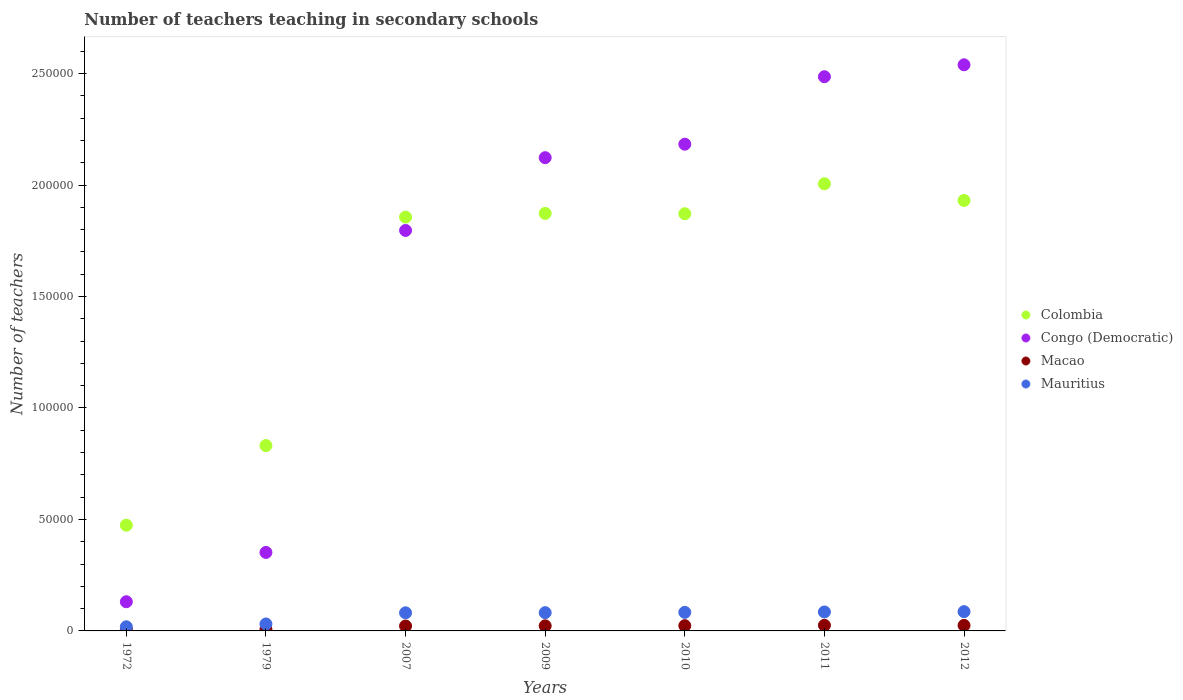What is the number of teachers teaching in secondary schools in Congo (Democratic) in 2007?
Provide a short and direct response. 1.80e+05. Across all years, what is the maximum number of teachers teaching in secondary schools in Colombia?
Provide a short and direct response. 2.01e+05. Across all years, what is the minimum number of teachers teaching in secondary schools in Macao?
Ensure brevity in your answer.  668. In which year was the number of teachers teaching in secondary schools in Macao maximum?
Keep it short and to the point. 2011. In which year was the number of teachers teaching in secondary schools in Congo (Democratic) minimum?
Give a very brief answer. 1972. What is the total number of teachers teaching in secondary schools in Mauritius in the graph?
Keep it short and to the point. 4.68e+04. What is the difference between the number of teachers teaching in secondary schools in Macao in 2010 and that in 2011?
Offer a terse response. -168. What is the difference between the number of teachers teaching in secondary schools in Congo (Democratic) in 1972 and the number of teachers teaching in secondary schools in Macao in 2010?
Offer a terse response. 1.07e+04. What is the average number of teachers teaching in secondary schools in Mauritius per year?
Your answer should be compact. 6680.57. In the year 2007, what is the difference between the number of teachers teaching in secondary schools in Macao and number of teachers teaching in secondary schools in Mauritius?
Keep it short and to the point. -5914. What is the ratio of the number of teachers teaching in secondary schools in Colombia in 1979 to that in 2007?
Ensure brevity in your answer.  0.45. Is the number of teachers teaching in secondary schools in Macao in 1972 less than that in 2012?
Give a very brief answer. Yes. Is the difference between the number of teachers teaching in secondary schools in Macao in 1972 and 2009 greater than the difference between the number of teachers teaching in secondary schools in Mauritius in 1972 and 2009?
Give a very brief answer. Yes. What is the difference between the highest and the second highest number of teachers teaching in secondary schools in Mauritius?
Offer a terse response. 136. What is the difference between the highest and the lowest number of teachers teaching in secondary schools in Mauritius?
Offer a terse response. 6787. Is the sum of the number of teachers teaching in secondary schools in Congo (Democratic) in 2009 and 2012 greater than the maximum number of teachers teaching in secondary schools in Macao across all years?
Your response must be concise. Yes. Is it the case that in every year, the sum of the number of teachers teaching in secondary schools in Mauritius and number of teachers teaching in secondary schools in Macao  is greater than the number of teachers teaching in secondary schools in Congo (Democratic)?
Give a very brief answer. No. Is the number of teachers teaching in secondary schools in Macao strictly less than the number of teachers teaching in secondary schools in Congo (Democratic) over the years?
Your response must be concise. Yes. How many dotlines are there?
Offer a terse response. 4. How many years are there in the graph?
Ensure brevity in your answer.  7. Are the values on the major ticks of Y-axis written in scientific E-notation?
Make the answer very short. No. What is the title of the graph?
Ensure brevity in your answer.  Number of teachers teaching in secondary schools. Does "Least developed countries" appear as one of the legend labels in the graph?
Make the answer very short. No. What is the label or title of the Y-axis?
Ensure brevity in your answer.  Number of teachers. What is the Number of teachers of Colombia in 1972?
Your answer should be compact. 4.74e+04. What is the Number of teachers of Congo (Democratic) in 1972?
Give a very brief answer. 1.31e+04. What is the Number of teachers in Macao in 1972?
Ensure brevity in your answer.  668. What is the Number of teachers in Mauritius in 1972?
Offer a very short reply. 1856. What is the Number of teachers of Colombia in 1979?
Keep it short and to the point. 8.31e+04. What is the Number of teachers of Congo (Democratic) in 1979?
Provide a short and direct response. 3.52e+04. What is the Number of teachers in Macao in 1979?
Your response must be concise. 716. What is the Number of teachers in Mauritius in 1979?
Your response must be concise. 3125. What is the Number of teachers of Colombia in 2007?
Give a very brief answer. 1.86e+05. What is the Number of teachers in Congo (Democratic) in 2007?
Provide a succinct answer. 1.80e+05. What is the Number of teachers in Macao in 2007?
Ensure brevity in your answer.  2210. What is the Number of teachers in Mauritius in 2007?
Give a very brief answer. 8124. What is the Number of teachers of Colombia in 2009?
Offer a very short reply. 1.87e+05. What is the Number of teachers in Congo (Democratic) in 2009?
Provide a succinct answer. 2.12e+05. What is the Number of teachers in Macao in 2009?
Your response must be concise. 2294. What is the Number of teachers in Mauritius in 2009?
Give a very brief answer. 8186. What is the Number of teachers in Colombia in 2010?
Keep it short and to the point. 1.87e+05. What is the Number of teachers of Congo (Democratic) in 2010?
Give a very brief answer. 2.18e+05. What is the Number of teachers in Macao in 2010?
Keep it short and to the point. 2355. What is the Number of teachers of Mauritius in 2010?
Offer a very short reply. 8323. What is the Number of teachers in Colombia in 2011?
Ensure brevity in your answer.  2.01e+05. What is the Number of teachers in Congo (Democratic) in 2011?
Ensure brevity in your answer.  2.49e+05. What is the Number of teachers in Macao in 2011?
Your answer should be very brief. 2523. What is the Number of teachers of Mauritius in 2011?
Keep it short and to the point. 8507. What is the Number of teachers of Colombia in 2012?
Give a very brief answer. 1.93e+05. What is the Number of teachers in Congo (Democratic) in 2012?
Offer a very short reply. 2.54e+05. What is the Number of teachers of Macao in 2012?
Your answer should be very brief. 2480. What is the Number of teachers in Mauritius in 2012?
Your response must be concise. 8643. Across all years, what is the maximum Number of teachers in Colombia?
Your answer should be very brief. 2.01e+05. Across all years, what is the maximum Number of teachers in Congo (Democratic)?
Give a very brief answer. 2.54e+05. Across all years, what is the maximum Number of teachers of Macao?
Provide a short and direct response. 2523. Across all years, what is the maximum Number of teachers in Mauritius?
Your answer should be very brief. 8643. Across all years, what is the minimum Number of teachers of Colombia?
Your answer should be compact. 4.74e+04. Across all years, what is the minimum Number of teachers of Congo (Democratic)?
Offer a very short reply. 1.31e+04. Across all years, what is the minimum Number of teachers in Macao?
Provide a succinct answer. 668. Across all years, what is the minimum Number of teachers of Mauritius?
Keep it short and to the point. 1856. What is the total Number of teachers of Colombia in the graph?
Give a very brief answer. 1.08e+06. What is the total Number of teachers in Congo (Democratic) in the graph?
Provide a succinct answer. 1.16e+06. What is the total Number of teachers in Macao in the graph?
Keep it short and to the point. 1.32e+04. What is the total Number of teachers of Mauritius in the graph?
Provide a succinct answer. 4.68e+04. What is the difference between the Number of teachers of Colombia in 1972 and that in 1979?
Provide a succinct answer. -3.57e+04. What is the difference between the Number of teachers in Congo (Democratic) in 1972 and that in 1979?
Your response must be concise. -2.21e+04. What is the difference between the Number of teachers in Macao in 1972 and that in 1979?
Make the answer very short. -48. What is the difference between the Number of teachers of Mauritius in 1972 and that in 1979?
Offer a very short reply. -1269. What is the difference between the Number of teachers in Colombia in 1972 and that in 2007?
Keep it short and to the point. -1.38e+05. What is the difference between the Number of teachers in Congo (Democratic) in 1972 and that in 2007?
Keep it short and to the point. -1.67e+05. What is the difference between the Number of teachers in Macao in 1972 and that in 2007?
Ensure brevity in your answer.  -1542. What is the difference between the Number of teachers of Mauritius in 1972 and that in 2007?
Offer a very short reply. -6268. What is the difference between the Number of teachers of Colombia in 1972 and that in 2009?
Make the answer very short. -1.40e+05. What is the difference between the Number of teachers in Congo (Democratic) in 1972 and that in 2009?
Make the answer very short. -1.99e+05. What is the difference between the Number of teachers in Macao in 1972 and that in 2009?
Your answer should be very brief. -1626. What is the difference between the Number of teachers in Mauritius in 1972 and that in 2009?
Make the answer very short. -6330. What is the difference between the Number of teachers of Colombia in 1972 and that in 2010?
Make the answer very short. -1.40e+05. What is the difference between the Number of teachers in Congo (Democratic) in 1972 and that in 2010?
Offer a very short reply. -2.05e+05. What is the difference between the Number of teachers of Macao in 1972 and that in 2010?
Keep it short and to the point. -1687. What is the difference between the Number of teachers in Mauritius in 1972 and that in 2010?
Give a very brief answer. -6467. What is the difference between the Number of teachers in Colombia in 1972 and that in 2011?
Keep it short and to the point. -1.53e+05. What is the difference between the Number of teachers in Congo (Democratic) in 1972 and that in 2011?
Provide a succinct answer. -2.36e+05. What is the difference between the Number of teachers of Macao in 1972 and that in 2011?
Ensure brevity in your answer.  -1855. What is the difference between the Number of teachers in Mauritius in 1972 and that in 2011?
Ensure brevity in your answer.  -6651. What is the difference between the Number of teachers of Colombia in 1972 and that in 2012?
Give a very brief answer. -1.46e+05. What is the difference between the Number of teachers of Congo (Democratic) in 1972 and that in 2012?
Your response must be concise. -2.41e+05. What is the difference between the Number of teachers of Macao in 1972 and that in 2012?
Your answer should be very brief. -1812. What is the difference between the Number of teachers in Mauritius in 1972 and that in 2012?
Your answer should be very brief. -6787. What is the difference between the Number of teachers of Colombia in 1979 and that in 2007?
Offer a very short reply. -1.02e+05. What is the difference between the Number of teachers of Congo (Democratic) in 1979 and that in 2007?
Give a very brief answer. -1.44e+05. What is the difference between the Number of teachers in Macao in 1979 and that in 2007?
Your response must be concise. -1494. What is the difference between the Number of teachers of Mauritius in 1979 and that in 2007?
Give a very brief answer. -4999. What is the difference between the Number of teachers in Colombia in 1979 and that in 2009?
Keep it short and to the point. -1.04e+05. What is the difference between the Number of teachers of Congo (Democratic) in 1979 and that in 2009?
Provide a short and direct response. -1.77e+05. What is the difference between the Number of teachers of Macao in 1979 and that in 2009?
Offer a very short reply. -1578. What is the difference between the Number of teachers in Mauritius in 1979 and that in 2009?
Your answer should be compact. -5061. What is the difference between the Number of teachers of Colombia in 1979 and that in 2010?
Provide a succinct answer. -1.04e+05. What is the difference between the Number of teachers of Congo (Democratic) in 1979 and that in 2010?
Keep it short and to the point. -1.83e+05. What is the difference between the Number of teachers in Macao in 1979 and that in 2010?
Offer a terse response. -1639. What is the difference between the Number of teachers in Mauritius in 1979 and that in 2010?
Give a very brief answer. -5198. What is the difference between the Number of teachers of Colombia in 1979 and that in 2011?
Keep it short and to the point. -1.17e+05. What is the difference between the Number of teachers in Congo (Democratic) in 1979 and that in 2011?
Your answer should be compact. -2.13e+05. What is the difference between the Number of teachers of Macao in 1979 and that in 2011?
Your answer should be compact. -1807. What is the difference between the Number of teachers of Mauritius in 1979 and that in 2011?
Your response must be concise. -5382. What is the difference between the Number of teachers in Colombia in 1979 and that in 2012?
Give a very brief answer. -1.10e+05. What is the difference between the Number of teachers of Congo (Democratic) in 1979 and that in 2012?
Offer a terse response. -2.19e+05. What is the difference between the Number of teachers in Macao in 1979 and that in 2012?
Offer a terse response. -1764. What is the difference between the Number of teachers of Mauritius in 1979 and that in 2012?
Offer a terse response. -5518. What is the difference between the Number of teachers of Colombia in 2007 and that in 2009?
Offer a terse response. -1657. What is the difference between the Number of teachers in Congo (Democratic) in 2007 and that in 2009?
Ensure brevity in your answer.  -3.26e+04. What is the difference between the Number of teachers in Macao in 2007 and that in 2009?
Offer a very short reply. -84. What is the difference between the Number of teachers in Mauritius in 2007 and that in 2009?
Your answer should be very brief. -62. What is the difference between the Number of teachers in Colombia in 2007 and that in 2010?
Make the answer very short. -1506. What is the difference between the Number of teachers in Congo (Democratic) in 2007 and that in 2010?
Offer a terse response. -3.87e+04. What is the difference between the Number of teachers of Macao in 2007 and that in 2010?
Ensure brevity in your answer.  -145. What is the difference between the Number of teachers of Mauritius in 2007 and that in 2010?
Your answer should be compact. -199. What is the difference between the Number of teachers of Colombia in 2007 and that in 2011?
Offer a very short reply. -1.49e+04. What is the difference between the Number of teachers of Congo (Democratic) in 2007 and that in 2011?
Offer a terse response. -6.90e+04. What is the difference between the Number of teachers in Macao in 2007 and that in 2011?
Your answer should be compact. -313. What is the difference between the Number of teachers in Mauritius in 2007 and that in 2011?
Keep it short and to the point. -383. What is the difference between the Number of teachers in Colombia in 2007 and that in 2012?
Provide a short and direct response. -7469. What is the difference between the Number of teachers in Congo (Democratic) in 2007 and that in 2012?
Your response must be concise. -7.43e+04. What is the difference between the Number of teachers of Macao in 2007 and that in 2012?
Give a very brief answer. -270. What is the difference between the Number of teachers in Mauritius in 2007 and that in 2012?
Your answer should be very brief. -519. What is the difference between the Number of teachers of Colombia in 2009 and that in 2010?
Keep it short and to the point. 151. What is the difference between the Number of teachers in Congo (Democratic) in 2009 and that in 2010?
Your answer should be very brief. -6047. What is the difference between the Number of teachers in Macao in 2009 and that in 2010?
Provide a short and direct response. -61. What is the difference between the Number of teachers of Mauritius in 2009 and that in 2010?
Ensure brevity in your answer.  -137. What is the difference between the Number of teachers of Colombia in 2009 and that in 2011?
Provide a short and direct response. -1.33e+04. What is the difference between the Number of teachers of Congo (Democratic) in 2009 and that in 2011?
Your answer should be compact. -3.63e+04. What is the difference between the Number of teachers of Macao in 2009 and that in 2011?
Provide a succinct answer. -229. What is the difference between the Number of teachers of Mauritius in 2009 and that in 2011?
Provide a short and direct response. -321. What is the difference between the Number of teachers of Colombia in 2009 and that in 2012?
Make the answer very short. -5812. What is the difference between the Number of teachers in Congo (Democratic) in 2009 and that in 2012?
Ensure brevity in your answer.  -4.17e+04. What is the difference between the Number of teachers of Macao in 2009 and that in 2012?
Offer a terse response. -186. What is the difference between the Number of teachers of Mauritius in 2009 and that in 2012?
Your answer should be very brief. -457. What is the difference between the Number of teachers of Colombia in 2010 and that in 2011?
Give a very brief answer. -1.34e+04. What is the difference between the Number of teachers in Congo (Democratic) in 2010 and that in 2011?
Make the answer very short. -3.03e+04. What is the difference between the Number of teachers in Macao in 2010 and that in 2011?
Offer a very short reply. -168. What is the difference between the Number of teachers of Mauritius in 2010 and that in 2011?
Offer a very short reply. -184. What is the difference between the Number of teachers of Colombia in 2010 and that in 2012?
Make the answer very short. -5963. What is the difference between the Number of teachers of Congo (Democratic) in 2010 and that in 2012?
Offer a very short reply. -3.56e+04. What is the difference between the Number of teachers of Macao in 2010 and that in 2012?
Ensure brevity in your answer.  -125. What is the difference between the Number of teachers of Mauritius in 2010 and that in 2012?
Provide a succinct answer. -320. What is the difference between the Number of teachers in Colombia in 2011 and that in 2012?
Offer a terse response. 7480. What is the difference between the Number of teachers of Congo (Democratic) in 2011 and that in 2012?
Your answer should be very brief. -5338. What is the difference between the Number of teachers of Mauritius in 2011 and that in 2012?
Provide a succinct answer. -136. What is the difference between the Number of teachers in Colombia in 1972 and the Number of teachers in Congo (Democratic) in 1979?
Provide a short and direct response. 1.22e+04. What is the difference between the Number of teachers of Colombia in 1972 and the Number of teachers of Macao in 1979?
Give a very brief answer. 4.67e+04. What is the difference between the Number of teachers in Colombia in 1972 and the Number of teachers in Mauritius in 1979?
Provide a short and direct response. 4.43e+04. What is the difference between the Number of teachers of Congo (Democratic) in 1972 and the Number of teachers of Macao in 1979?
Offer a very short reply. 1.24e+04. What is the difference between the Number of teachers of Congo (Democratic) in 1972 and the Number of teachers of Mauritius in 1979?
Provide a short and direct response. 9962. What is the difference between the Number of teachers of Macao in 1972 and the Number of teachers of Mauritius in 1979?
Offer a very short reply. -2457. What is the difference between the Number of teachers of Colombia in 1972 and the Number of teachers of Congo (Democratic) in 2007?
Your answer should be compact. -1.32e+05. What is the difference between the Number of teachers in Colombia in 1972 and the Number of teachers in Macao in 2007?
Provide a short and direct response. 4.52e+04. What is the difference between the Number of teachers of Colombia in 1972 and the Number of teachers of Mauritius in 2007?
Offer a terse response. 3.93e+04. What is the difference between the Number of teachers in Congo (Democratic) in 1972 and the Number of teachers in Macao in 2007?
Provide a short and direct response. 1.09e+04. What is the difference between the Number of teachers of Congo (Democratic) in 1972 and the Number of teachers of Mauritius in 2007?
Ensure brevity in your answer.  4963. What is the difference between the Number of teachers of Macao in 1972 and the Number of teachers of Mauritius in 2007?
Provide a succinct answer. -7456. What is the difference between the Number of teachers of Colombia in 1972 and the Number of teachers of Congo (Democratic) in 2009?
Keep it short and to the point. -1.65e+05. What is the difference between the Number of teachers of Colombia in 1972 and the Number of teachers of Macao in 2009?
Provide a short and direct response. 4.51e+04. What is the difference between the Number of teachers of Colombia in 1972 and the Number of teachers of Mauritius in 2009?
Offer a very short reply. 3.92e+04. What is the difference between the Number of teachers in Congo (Democratic) in 1972 and the Number of teachers in Macao in 2009?
Ensure brevity in your answer.  1.08e+04. What is the difference between the Number of teachers in Congo (Democratic) in 1972 and the Number of teachers in Mauritius in 2009?
Make the answer very short. 4901. What is the difference between the Number of teachers of Macao in 1972 and the Number of teachers of Mauritius in 2009?
Your answer should be very brief. -7518. What is the difference between the Number of teachers in Colombia in 1972 and the Number of teachers in Congo (Democratic) in 2010?
Your response must be concise. -1.71e+05. What is the difference between the Number of teachers of Colombia in 1972 and the Number of teachers of Macao in 2010?
Provide a short and direct response. 4.51e+04. What is the difference between the Number of teachers in Colombia in 1972 and the Number of teachers in Mauritius in 2010?
Your answer should be compact. 3.91e+04. What is the difference between the Number of teachers in Congo (Democratic) in 1972 and the Number of teachers in Macao in 2010?
Ensure brevity in your answer.  1.07e+04. What is the difference between the Number of teachers in Congo (Democratic) in 1972 and the Number of teachers in Mauritius in 2010?
Offer a terse response. 4764. What is the difference between the Number of teachers in Macao in 1972 and the Number of teachers in Mauritius in 2010?
Give a very brief answer. -7655. What is the difference between the Number of teachers in Colombia in 1972 and the Number of teachers in Congo (Democratic) in 2011?
Offer a terse response. -2.01e+05. What is the difference between the Number of teachers in Colombia in 1972 and the Number of teachers in Macao in 2011?
Provide a succinct answer. 4.49e+04. What is the difference between the Number of teachers of Colombia in 1972 and the Number of teachers of Mauritius in 2011?
Give a very brief answer. 3.89e+04. What is the difference between the Number of teachers in Congo (Democratic) in 1972 and the Number of teachers in Macao in 2011?
Offer a terse response. 1.06e+04. What is the difference between the Number of teachers in Congo (Democratic) in 1972 and the Number of teachers in Mauritius in 2011?
Keep it short and to the point. 4580. What is the difference between the Number of teachers of Macao in 1972 and the Number of teachers of Mauritius in 2011?
Ensure brevity in your answer.  -7839. What is the difference between the Number of teachers of Colombia in 1972 and the Number of teachers of Congo (Democratic) in 2012?
Give a very brief answer. -2.07e+05. What is the difference between the Number of teachers of Colombia in 1972 and the Number of teachers of Macao in 2012?
Offer a very short reply. 4.49e+04. What is the difference between the Number of teachers in Colombia in 1972 and the Number of teachers in Mauritius in 2012?
Offer a very short reply. 3.88e+04. What is the difference between the Number of teachers of Congo (Democratic) in 1972 and the Number of teachers of Macao in 2012?
Keep it short and to the point. 1.06e+04. What is the difference between the Number of teachers of Congo (Democratic) in 1972 and the Number of teachers of Mauritius in 2012?
Ensure brevity in your answer.  4444. What is the difference between the Number of teachers of Macao in 1972 and the Number of teachers of Mauritius in 2012?
Your response must be concise. -7975. What is the difference between the Number of teachers of Colombia in 1979 and the Number of teachers of Congo (Democratic) in 2007?
Provide a short and direct response. -9.65e+04. What is the difference between the Number of teachers of Colombia in 1979 and the Number of teachers of Macao in 2007?
Make the answer very short. 8.09e+04. What is the difference between the Number of teachers of Colombia in 1979 and the Number of teachers of Mauritius in 2007?
Provide a succinct answer. 7.50e+04. What is the difference between the Number of teachers of Congo (Democratic) in 1979 and the Number of teachers of Macao in 2007?
Provide a short and direct response. 3.30e+04. What is the difference between the Number of teachers of Congo (Democratic) in 1979 and the Number of teachers of Mauritius in 2007?
Give a very brief answer. 2.71e+04. What is the difference between the Number of teachers in Macao in 1979 and the Number of teachers in Mauritius in 2007?
Your answer should be compact. -7408. What is the difference between the Number of teachers of Colombia in 1979 and the Number of teachers of Congo (Democratic) in 2009?
Offer a very short reply. -1.29e+05. What is the difference between the Number of teachers of Colombia in 1979 and the Number of teachers of Macao in 2009?
Offer a very short reply. 8.08e+04. What is the difference between the Number of teachers of Colombia in 1979 and the Number of teachers of Mauritius in 2009?
Provide a succinct answer. 7.49e+04. What is the difference between the Number of teachers of Congo (Democratic) in 1979 and the Number of teachers of Macao in 2009?
Offer a terse response. 3.29e+04. What is the difference between the Number of teachers of Congo (Democratic) in 1979 and the Number of teachers of Mauritius in 2009?
Offer a very short reply. 2.70e+04. What is the difference between the Number of teachers of Macao in 1979 and the Number of teachers of Mauritius in 2009?
Provide a short and direct response. -7470. What is the difference between the Number of teachers of Colombia in 1979 and the Number of teachers of Congo (Democratic) in 2010?
Keep it short and to the point. -1.35e+05. What is the difference between the Number of teachers in Colombia in 1979 and the Number of teachers in Macao in 2010?
Ensure brevity in your answer.  8.08e+04. What is the difference between the Number of teachers in Colombia in 1979 and the Number of teachers in Mauritius in 2010?
Provide a succinct answer. 7.48e+04. What is the difference between the Number of teachers in Congo (Democratic) in 1979 and the Number of teachers in Macao in 2010?
Provide a short and direct response. 3.29e+04. What is the difference between the Number of teachers of Congo (Democratic) in 1979 and the Number of teachers of Mauritius in 2010?
Your response must be concise. 2.69e+04. What is the difference between the Number of teachers in Macao in 1979 and the Number of teachers in Mauritius in 2010?
Offer a terse response. -7607. What is the difference between the Number of teachers of Colombia in 1979 and the Number of teachers of Congo (Democratic) in 2011?
Your answer should be compact. -1.65e+05. What is the difference between the Number of teachers in Colombia in 1979 and the Number of teachers in Macao in 2011?
Make the answer very short. 8.06e+04. What is the difference between the Number of teachers in Colombia in 1979 and the Number of teachers in Mauritius in 2011?
Ensure brevity in your answer.  7.46e+04. What is the difference between the Number of teachers of Congo (Democratic) in 1979 and the Number of teachers of Macao in 2011?
Make the answer very short. 3.27e+04. What is the difference between the Number of teachers in Congo (Democratic) in 1979 and the Number of teachers in Mauritius in 2011?
Ensure brevity in your answer.  2.67e+04. What is the difference between the Number of teachers in Macao in 1979 and the Number of teachers in Mauritius in 2011?
Make the answer very short. -7791. What is the difference between the Number of teachers of Colombia in 1979 and the Number of teachers of Congo (Democratic) in 2012?
Make the answer very short. -1.71e+05. What is the difference between the Number of teachers in Colombia in 1979 and the Number of teachers in Macao in 2012?
Provide a succinct answer. 8.07e+04. What is the difference between the Number of teachers in Colombia in 1979 and the Number of teachers in Mauritius in 2012?
Ensure brevity in your answer.  7.45e+04. What is the difference between the Number of teachers of Congo (Democratic) in 1979 and the Number of teachers of Macao in 2012?
Your answer should be compact. 3.27e+04. What is the difference between the Number of teachers of Congo (Democratic) in 1979 and the Number of teachers of Mauritius in 2012?
Ensure brevity in your answer.  2.66e+04. What is the difference between the Number of teachers of Macao in 1979 and the Number of teachers of Mauritius in 2012?
Make the answer very short. -7927. What is the difference between the Number of teachers in Colombia in 2007 and the Number of teachers in Congo (Democratic) in 2009?
Provide a short and direct response. -2.67e+04. What is the difference between the Number of teachers of Colombia in 2007 and the Number of teachers of Macao in 2009?
Your answer should be compact. 1.83e+05. What is the difference between the Number of teachers in Colombia in 2007 and the Number of teachers in Mauritius in 2009?
Your answer should be compact. 1.77e+05. What is the difference between the Number of teachers in Congo (Democratic) in 2007 and the Number of teachers in Macao in 2009?
Make the answer very short. 1.77e+05. What is the difference between the Number of teachers of Congo (Democratic) in 2007 and the Number of teachers of Mauritius in 2009?
Provide a short and direct response. 1.71e+05. What is the difference between the Number of teachers of Macao in 2007 and the Number of teachers of Mauritius in 2009?
Offer a terse response. -5976. What is the difference between the Number of teachers in Colombia in 2007 and the Number of teachers in Congo (Democratic) in 2010?
Make the answer very short. -3.27e+04. What is the difference between the Number of teachers of Colombia in 2007 and the Number of teachers of Macao in 2010?
Give a very brief answer. 1.83e+05. What is the difference between the Number of teachers in Colombia in 2007 and the Number of teachers in Mauritius in 2010?
Your answer should be compact. 1.77e+05. What is the difference between the Number of teachers of Congo (Democratic) in 2007 and the Number of teachers of Macao in 2010?
Give a very brief answer. 1.77e+05. What is the difference between the Number of teachers of Congo (Democratic) in 2007 and the Number of teachers of Mauritius in 2010?
Your answer should be very brief. 1.71e+05. What is the difference between the Number of teachers of Macao in 2007 and the Number of teachers of Mauritius in 2010?
Provide a short and direct response. -6113. What is the difference between the Number of teachers in Colombia in 2007 and the Number of teachers in Congo (Democratic) in 2011?
Make the answer very short. -6.30e+04. What is the difference between the Number of teachers in Colombia in 2007 and the Number of teachers in Macao in 2011?
Your response must be concise. 1.83e+05. What is the difference between the Number of teachers of Colombia in 2007 and the Number of teachers of Mauritius in 2011?
Your response must be concise. 1.77e+05. What is the difference between the Number of teachers of Congo (Democratic) in 2007 and the Number of teachers of Macao in 2011?
Offer a very short reply. 1.77e+05. What is the difference between the Number of teachers of Congo (Democratic) in 2007 and the Number of teachers of Mauritius in 2011?
Keep it short and to the point. 1.71e+05. What is the difference between the Number of teachers in Macao in 2007 and the Number of teachers in Mauritius in 2011?
Provide a succinct answer. -6297. What is the difference between the Number of teachers in Colombia in 2007 and the Number of teachers in Congo (Democratic) in 2012?
Offer a very short reply. -6.83e+04. What is the difference between the Number of teachers in Colombia in 2007 and the Number of teachers in Macao in 2012?
Make the answer very short. 1.83e+05. What is the difference between the Number of teachers in Colombia in 2007 and the Number of teachers in Mauritius in 2012?
Give a very brief answer. 1.77e+05. What is the difference between the Number of teachers of Congo (Democratic) in 2007 and the Number of teachers of Macao in 2012?
Ensure brevity in your answer.  1.77e+05. What is the difference between the Number of teachers of Congo (Democratic) in 2007 and the Number of teachers of Mauritius in 2012?
Provide a succinct answer. 1.71e+05. What is the difference between the Number of teachers of Macao in 2007 and the Number of teachers of Mauritius in 2012?
Provide a short and direct response. -6433. What is the difference between the Number of teachers of Colombia in 2009 and the Number of teachers of Congo (Democratic) in 2010?
Provide a short and direct response. -3.10e+04. What is the difference between the Number of teachers in Colombia in 2009 and the Number of teachers in Macao in 2010?
Give a very brief answer. 1.85e+05. What is the difference between the Number of teachers of Colombia in 2009 and the Number of teachers of Mauritius in 2010?
Offer a very short reply. 1.79e+05. What is the difference between the Number of teachers in Congo (Democratic) in 2009 and the Number of teachers in Macao in 2010?
Your answer should be very brief. 2.10e+05. What is the difference between the Number of teachers of Congo (Democratic) in 2009 and the Number of teachers of Mauritius in 2010?
Make the answer very short. 2.04e+05. What is the difference between the Number of teachers in Macao in 2009 and the Number of teachers in Mauritius in 2010?
Offer a very short reply. -6029. What is the difference between the Number of teachers of Colombia in 2009 and the Number of teachers of Congo (Democratic) in 2011?
Provide a succinct answer. -6.13e+04. What is the difference between the Number of teachers of Colombia in 2009 and the Number of teachers of Macao in 2011?
Offer a terse response. 1.85e+05. What is the difference between the Number of teachers of Colombia in 2009 and the Number of teachers of Mauritius in 2011?
Your answer should be very brief. 1.79e+05. What is the difference between the Number of teachers of Congo (Democratic) in 2009 and the Number of teachers of Macao in 2011?
Give a very brief answer. 2.10e+05. What is the difference between the Number of teachers in Congo (Democratic) in 2009 and the Number of teachers in Mauritius in 2011?
Keep it short and to the point. 2.04e+05. What is the difference between the Number of teachers of Macao in 2009 and the Number of teachers of Mauritius in 2011?
Provide a succinct answer. -6213. What is the difference between the Number of teachers of Colombia in 2009 and the Number of teachers of Congo (Democratic) in 2012?
Your answer should be compact. -6.67e+04. What is the difference between the Number of teachers in Colombia in 2009 and the Number of teachers in Macao in 2012?
Make the answer very short. 1.85e+05. What is the difference between the Number of teachers in Colombia in 2009 and the Number of teachers in Mauritius in 2012?
Offer a very short reply. 1.79e+05. What is the difference between the Number of teachers of Congo (Democratic) in 2009 and the Number of teachers of Macao in 2012?
Ensure brevity in your answer.  2.10e+05. What is the difference between the Number of teachers in Congo (Democratic) in 2009 and the Number of teachers in Mauritius in 2012?
Your answer should be very brief. 2.04e+05. What is the difference between the Number of teachers in Macao in 2009 and the Number of teachers in Mauritius in 2012?
Your answer should be very brief. -6349. What is the difference between the Number of teachers of Colombia in 2010 and the Number of teachers of Congo (Democratic) in 2011?
Your answer should be very brief. -6.15e+04. What is the difference between the Number of teachers of Colombia in 2010 and the Number of teachers of Macao in 2011?
Give a very brief answer. 1.85e+05. What is the difference between the Number of teachers of Colombia in 2010 and the Number of teachers of Mauritius in 2011?
Keep it short and to the point. 1.79e+05. What is the difference between the Number of teachers in Congo (Democratic) in 2010 and the Number of teachers in Macao in 2011?
Your response must be concise. 2.16e+05. What is the difference between the Number of teachers in Congo (Democratic) in 2010 and the Number of teachers in Mauritius in 2011?
Offer a very short reply. 2.10e+05. What is the difference between the Number of teachers in Macao in 2010 and the Number of teachers in Mauritius in 2011?
Ensure brevity in your answer.  -6152. What is the difference between the Number of teachers in Colombia in 2010 and the Number of teachers in Congo (Democratic) in 2012?
Your answer should be compact. -6.68e+04. What is the difference between the Number of teachers in Colombia in 2010 and the Number of teachers in Macao in 2012?
Offer a terse response. 1.85e+05. What is the difference between the Number of teachers in Colombia in 2010 and the Number of teachers in Mauritius in 2012?
Your answer should be very brief. 1.78e+05. What is the difference between the Number of teachers in Congo (Democratic) in 2010 and the Number of teachers in Macao in 2012?
Your answer should be very brief. 2.16e+05. What is the difference between the Number of teachers in Congo (Democratic) in 2010 and the Number of teachers in Mauritius in 2012?
Make the answer very short. 2.10e+05. What is the difference between the Number of teachers of Macao in 2010 and the Number of teachers of Mauritius in 2012?
Keep it short and to the point. -6288. What is the difference between the Number of teachers in Colombia in 2011 and the Number of teachers in Congo (Democratic) in 2012?
Your answer should be very brief. -5.34e+04. What is the difference between the Number of teachers of Colombia in 2011 and the Number of teachers of Macao in 2012?
Your answer should be very brief. 1.98e+05. What is the difference between the Number of teachers of Colombia in 2011 and the Number of teachers of Mauritius in 2012?
Keep it short and to the point. 1.92e+05. What is the difference between the Number of teachers in Congo (Democratic) in 2011 and the Number of teachers in Macao in 2012?
Your response must be concise. 2.46e+05. What is the difference between the Number of teachers of Congo (Democratic) in 2011 and the Number of teachers of Mauritius in 2012?
Your response must be concise. 2.40e+05. What is the difference between the Number of teachers of Macao in 2011 and the Number of teachers of Mauritius in 2012?
Your answer should be compact. -6120. What is the average Number of teachers in Colombia per year?
Ensure brevity in your answer.  1.55e+05. What is the average Number of teachers in Congo (Democratic) per year?
Provide a succinct answer. 1.66e+05. What is the average Number of teachers of Macao per year?
Provide a short and direct response. 1892.29. What is the average Number of teachers in Mauritius per year?
Offer a terse response. 6680.57. In the year 1972, what is the difference between the Number of teachers of Colombia and Number of teachers of Congo (Democratic)?
Offer a terse response. 3.43e+04. In the year 1972, what is the difference between the Number of teachers of Colombia and Number of teachers of Macao?
Your response must be concise. 4.68e+04. In the year 1972, what is the difference between the Number of teachers in Colombia and Number of teachers in Mauritius?
Your response must be concise. 4.56e+04. In the year 1972, what is the difference between the Number of teachers of Congo (Democratic) and Number of teachers of Macao?
Your answer should be compact. 1.24e+04. In the year 1972, what is the difference between the Number of teachers of Congo (Democratic) and Number of teachers of Mauritius?
Ensure brevity in your answer.  1.12e+04. In the year 1972, what is the difference between the Number of teachers of Macao and Number of teachers of Mauritius?
Provide a short and direct response. -1188. In the year 1979, what is the difference between the Number of teachers in Colombia and Number of teachers in Congo (Democratic)?
Your answer should be compact. 4.79e+04. In the year 1979, what is the difference between the Number of teachers in Colombia and Number of teachers in Macao?
Your answer should be very brief. 8.24e+04. In the year 1979, what is the difference between the Number of teachers in Colombia and Number of teachers in Mauritius?
Ensure brevity in your answer.  8.00e+04. In the year 1979, what is the difference between the Number of teachers of Congo (Democratic) and Number of teachers of Macao?
Your answer should be very brief. 3.45e+04. In the year 1979, what is the difference between the Number of teachers of Congo (Democratic) and Number of teachers of Mauritius?
Offer a terse response. 3.21e+04. In the year 1979, what is the difference between the Number of teachers of Macao and Number of teachers of Mauritius?
Your answer should be compact. -2409. In the year 2007, what is the difference between the Number of teachers of Colombia and Number of teachers of Congo (Democratic)?
Keep it short and to the point. 5983. In the year 2007, what is the difference between the Number of teachers of Colombia and Number of teachers of Macao?
Your answer should be very brief. 1.83e+05. In the year 2007, what is the difference between the Number of teachers of Colombia and Number of teachers of Mauritius?
Provide a short and direct response. 1.77e+05. In the year 2007, what is the difference between the Number of teachers in Congo (Democratic) and Number of teachers in Macao?
Your answer should be very brief. 1.77e+05. In the year 2007, what is the difference between the Number of teachers in Congo (Democratic) and Number of teachers in Mauritius?
Give a very brief answer. 1.72e+05. In the year 2007, what is the difference between the Number of teachers of Macao and Number of teachers of Mauritius?
Make the answer very short. -5914. In the year 2009, what is the difference between the Number of teachers of Colombia and Number of teachers of Congo (Democratic)?
Keep it short and to the point. -2.50e+04. In the year 2009, what is the difference between the Number of teachers of Colombia and Number of teachers of Macao?
Keep it short and to the point. 1.85e+05. In the year 2009, what is the difference between the Number of teachers in Colombia and Number of teachers in Mauritius?
Give a very brief answer. 1.79e+05. In the year 2009, what is the difference between the Number of teachers in Congo (Democratic) and Number of teachers in Macao?
Your response must be concise. 2.10e+05. In the year 2009, what is the difference between the Number of teachers of Congo (Democratic) and Number of teachers of Mauritius?
Offer a very short reply. 2.04e+05. In the year 2009, what is the difference between the Number of teachers in Macao and Number of teachers in Mauritius?
Your answer should be compact. -5892. In the year 2010, what is the difference between the Number of teachers in Colombia and Number of teachers in Congo (Democratic)?
Your answer should be compact. -3.12e+04. In the year 2010, what is the difference between the Number of teachers of Colombia and Number of teachers of Macao?
Offer a terse response. 1.85e+05. In the year 2010, what is the difference between the Number of teachers of Colombia and Number of teachers of Mauritius?
Your answer should be very brief. 1.79e+05. In the year 2010, what is the difference between the Number of teachers of Congo (Democratic) and Number of teachers of Macao?
Your response must be concise. 2.16e+05. In the year 2010, what is the difference between the Number of teachers in Congo (Democratic) and Number of teachers in Mauritius?
Keep it short and to the point. 2.10e+05. In the year 2010, what is the difference between the Number of teachers of Macao and Number of teachers of Mauritius?
Your answer should be very brief. -5968. In the year 2011, what is the difference between the Number of teachers in Colombia and Number of teachers in Congo (Democratic)?
Offer a very short reply. -4.80e+04. In the year 2011, what is the difference between the Number of teachers of Colombia and Number of teachers of Macao?
Provide a short and direct response. 1.98e+05. In the year 2011, what is the difference between the Number of teachers of Colombia and Number of teachers of Mauritius?
Keep it short and to the point. 1.92e+05. In the year 2011, what is the difference between the Number of teachers of Congo (Democratic) and Number of teachers of Macao?
Offer a very short reply. 2.46e+05. In the year 2011, what is the difference between the Number of teachers of Congo (Democratic) and Number of teachers of Mauritius?
Provide a short and direct response. 2.40e+05. In the year 2011, what is the difference between the Number of teachers in Macao and Number of teachers in Mauritius?
Make the answer very short. -5984. In the year 2012, what is the difference between the Number of teachers of Colombia and Number of teachers of Congo (Democratic)?
Offer a terse response. -6.08e+04. In the year 2012, what is the difference between the Number of teachers in Colombia and Number of teachers in Macao?
Your answer should be very brief. 1.91e+05. In the year 2012, what is the difference between the Number of teachers of Colombia and Number of teachers of Mauritius?
Your answer should be compact. 1.84e+05. In the year 2012, what is the difference between the Number of teachers of Congo (Democratic) and Number of teachers of Macao?
Make the answer very short. 2.51e+05. In the year 2012, what is the difference between the Number of teachers in Congo (Democratic) and Number of teachers in Mauritius?
Keep it short and to the point. 2.45e+05. In the year 2012, what is the difference between the Number of teachers in Macao and Number of teachers in Mauritius?
Your answer should be compact. -6163. What is the ratio of the Number of teachers in Colombia in 1972 to that in 1979?
Your response must be concise. 0.57. What is the ratio of the Number of teachers of Congo (Democratic) in 1972 to that in 1979?
Your answer should be very brief. 0.37. What is the ratio of the Number of teachers of Macao in 1972 to that in 1979?
Offer a very short reply. 0.93. What is the ratio of the Number of teachers of Mauritius in 1972 to that in 1979?
Your answer should be very brief. 0.59. What is the ratio of the Number of teachers of Colombia in 1972 to that in 2007?
Keep it short and to the point. 0.26. What is the ratio of the Number of teachers of Congo (Democratic) in 1972 to that in 2007?
Your answer should be very brief. 0.07. What is the ratio of the Number of teachers in Macao in 1972 to that in 2007?
Make the answer very short. 0.3. What is the ratio of the Number of teachers of Mauritius in 1972 to that in 2007?
Make the answer very short. 0.23. What is the ratio of the Number of teachers in Colombia in 1972 to that in 2009?
Offer a terse response. 0.25. What is the ratio of the Number of teachers of Congo (Democratic) in 1972 to that in 2009?
Your response must be concise. 0.06. What is the ratio of the Number of teachers of Macao in 1972 to that in 2009?
Offer a very short reply. 0.29. What is the ratio of the Number of teachers in Mauritius in 1972 to that in 2009?
Provide a succinct answer. 0.23. What is the ratio of the Number of teachers in Colombia in 1972 to that in 2010?
Keep it short and to the point. 0.25. What is the ratio of the Number of teachers of Congo (Democratic) in 1972 to that in 2010?
Make the answer very short. 0.06. What is the ratio of the Number of teachers in Macao in 1972 to that in 2010?
Ensure brevity in your answer.  0.28. What is the ratio of the Number of teachers in Mauritius in 1972 to that in 2010?
Your answer should be very brief. 0.22. What is the ratio of the Number of teachers in Colombia in 1972 to that in 2011?
Your answer should be compact. 0.24. What is the ratio of the Number of teachers in Congo (Democratic) in 1972 to that in 2011?
Provide a succinct answer. 0.05. What is the ratio of the Number of teachers in Macao in 1972 to that in 2011?
Your answer should be compact. 0.26. What is the ratio of the Number of teachers of Mauritius in 1972 to that in 2011?
Give a very brief answer. 0.22. What is the ratio of the Number of teachers of Colombia in 1972 to that in 2012?
Provide a succinct answer. 0.25. What is the ratio of the Number of teachers of Congo (Democratic) in 1972 to that in 2012?
Provide a short and direct response. 0.05. What is the ratio of the Number of teachers of Macao in 1972 to that in 2012?
Provide a short and direct response. 0.27. What is the ratio of the Number of teachers of Mauritius in 1972 to that in 2012?
Provide a short and direct response. 0.21. What is the ratio of the Number of teachers in Colombia in 1979 to that in 2007?
Offer a very short reply. 0.45. What is the ratio of the Number of teachers of Congo (Democratic) in 1979 to that in 2007?
Offer a very short reply. 0.2. What is the ratio of the Number of teachers in Macao in 1979 to that in 2007?
Ensure brevity in your answer.  0.32. What is the ratio of the Number of teachers in Mauritius in 1979 to that in 2007?
Your response must be concise. 0.38. What is the ratio of the Number of teachers in Colombia in 1979 to that in 2009?
Offer a terse response. 0.44. What is the ratio of the Number of teachers in Congo (Democratic) in 1979 to that in 2009?
Make the answer very short. 0.17. What is the ratio of the Number of teachers of Macao in 1979 to that in 2009?
Keep it short and to the point. 0.31. What is the ratio of the Number of teachers in Mauritius in 1979 to that in 2009?
Your answer should be compact. 0.38. What is the ratio of the Number of teachers of Colombia in 1979 to that in 2010?
Make the answer very short. 0.44. What is the ratio of the Number of teachers in Congo (Democratic) in 1979 to that in 2010?
Ensure brevity in your answer.  0.16. What is the ratio of the Number of teachers of Macao in 1979 to that in 2010?
Ensure brevity in your answer.  0.3. What is the ratio of the Number of teachers in Mauritius in 1979 to that in 2010?
Offer a terse response. 0.38. What is the ratio of the Number of teachers in Colombia in 1979 to that in 2011?
Offer a terse response. 0.41. What is the ratio of the Number of teachers of Congo (Democratic) in 1979 to that in 2011?
Make the answer very short. 0.14. What is the ratio of the Number of teachers of Macao in 1979 to that in 2011?
Make the answer very short. 0.28. What is the ratio of the Number of teachers of Mauritius in 1979 to that in 2011?
Your response must be concise. 0.37. What is the ratio of the Number of teachers in Colombia in 1979 to that in 2012?
Offer a terse response. 0.43. What is the ratio of the Number of teachers in Congo (Democratic) in 1979 to that in 2012?
Offer a terse response. 0.14. What is the ratio of the Number of teachers in Macao in 1979 to that in 2012?
Provide a short and direct response. 0.29. What is the ratio of the Number of teachers in Mauritius in 1979 to that in 2012?
Ensure brevity in your answer.  0.36. What is the ratio of the Number of teachers in Colombia in 2007 to that in 2009?
Your response must be concise. 0.99. What is the ratio of the Number of teachers of Congo (Democratic) in 2007 to that in 2009?
Make the answer very short. 0.85. What is the ratio of the Number of teachers in Macao in 2007 to that in 2009?
Your answer should be compact. 0.96. What is the ratio of the Number of teachers in Mauritius in 2007 to that in 2009?
Your answer should be compact. 0.99. What is the ratio of the Number of teachers of Colombia in 2007 to that in 2010?
Provide a short and direct response. 0.99. What is the ratio of the Number of teachers in Congo (Democratic) in 2007 to that in 2010?
Offer a terse response. 0.82. What is the ratio of the Number of teachers in Macao in 2007 to that in 2010?
Offer a terse response. 0.94. What is the ratio of the Number of teachers in Mauritius in 2007 to that in 2010?
Provide a short and direct response. 0.98. What is the ratio of the Number of teachers of Colombia in 2007 to that in 2011?
Keep it short and to the point. 0.93. What is the ratio of the Number of teachers in Congo (Democratic) in 2007 to that in 2011?
Provide a short and direct response. 0.72. What is the ratio of the Number of teachers of Macao in 2007 to that in 2011?
Offer a very short reply. 0.88. What is the ratio of the Number of teachers of Mauritius in 2007 to that in 2011?
Give a very brief answer. 0.95. What is the ratio of the Number of teachers in Colombia in 2007 to that in 2012?
Your answer should be compact. 0.96. What is the ratio of the Number of teachers of Congo (Democratic) in 2007 to that in 2012?
Offer a terse response. 0.71. What is the ratio of the Number of teachers in Macao in 2007 to that in 2012?
Provide a short and direct response. 0.89. What is the ratio of the Number of teachers in Mauritius in 2007 to that in 2012?
Give a very brief answer. 0.94. What is the ratio of the Number of teachers in Colombia in 2009 to that in 2010?
Ensure brevity in your answer.  1. What is the ratio of the Number of teachers of Congo (Democratic) in 2009 to that in 2010?
Offer a very short reply. 0.97. What is the ratio of the Number of teachers in Macao in 2009 to that in 2010?
Provide a succinct answer. 0.97. What is the ratio of the Number of teachers of Mauritius in 2009 to that in 2010?
Your answer should be compact. 0.98. What is the ratio of the Number of teachers in Colombia in 2009 to that in 2011?
Provide a succinct answer. 0.93. What is the ratio of the Number of teachers in Congo (Democratic) in 2009 to that in 2011?
Your answer should be compact. 0.85. What is the ratio of the Number of teachers in Macao in 2009 to that in 2011?
Your answer should be compact. 0.91. What is the ratio of the Number of teachers in Mauritius in 2009 to that in 2011?
Your answer should be very brief. 0.96. What is the ratio of the Number of teachers in Colombia in 2009 to that in 2012?
Give a very brief answer. 0.97. What is the ratio of the Number of teachers of Congo (Democratic) in 2009 to that in 2012?
Offer a very short reply. 0.84. What is the ratio of the Number of teachers in Macao in 2009 to that in 2012?
Keep it short and to the point. 0.93. What is the ratio of the Number of teachers of Mauritius in 2009 to that in 2012?
Give a very brief answer. 0.95. What is the ratio of the Number of teachers in Colombia in 2010 to that in 2011?
Keep it short and to the point. 0.93. What is the ratio of the Number of teachers in Congo (Democratic) in 2010 to that in 2011?
Your answer should be compact. 0.88. What is the ratio of the Number of teachers of Macao in 2010 to that in 2011?
Offer a very short reply. 0.93. What is the ratio of the Number of teachers of Mauritius in 2010 to that in 2011?
Your response must be concise. 0.98. What is the ratio of the Number of teachers of Colombia in 2010 to that in 2012?
Your answer should be very brief. 0.97. What is the ratio of the Number of teachers in Congo (Democratic) in 2010 to that in 2012?
Your answer should be very brief. 0.86. What is the ratio of the Number of teachers in Macao in 2010 to that in 2012?
Offer a terse response. 0.95. What is the ratio of the Number of teachers of Mauritius in 2010 to that in 2012?
Give a very brief answer. 0.96. What is the ratio of the Number of teachers in Colombia in 2011 to that in 2012?
Provide a short and direct response. 1.04. What is the ratio of the Number of teachers of Macao in 2011 to that in 2012?
Make the answer very short. 1.02. What is the ratio of the Number of teachers in Mauritius in 2011 to that in 2012?
Ensure brevity in your answer.  0.98. What is the difference between the highest and the second highest Number of teachers of Colombia?
Your response must be concise. 7480. What is the difference between the highest and the second highest Number of teachers of Congo (Democratic)?
Your answer should be compact. 5338. What is the difference between the highest and the second highest Number of teachers in Mauritius?
Offer a terse response. 136. What is the difference between the highest and the lowest Number of teachers of Colombia?
Your answer should be compact. 1.53e+05. What is the difference between the highest and the lowest Number of teachers of Congo (Democratic)?
Ensure brevity in your answer.  2.41e+05. What is the difference between the highest and the lowest Number of teachers of Macao?
Your response must be concise. 1855. What is the difference between the highest and the lowest Number of teachers of Mauritius?
Your answer should be very brief. 6787. 